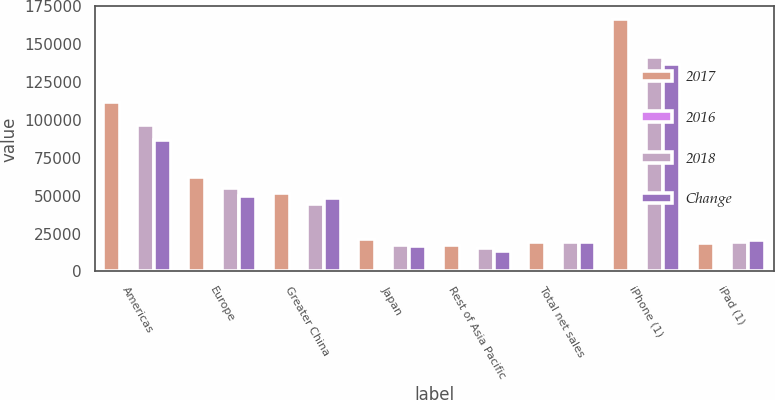<chart> <loc_0><loc_0><loc_500><loc_500><stacked_bar_chart><ecel><fcel>Americas<fcel>Europe<fcel>Greater China<fcel>Japan<fcel>Rest of Asia Pacific<fcel>Total net sales<fcel>iPhone (1)<fcel>iPad (1)<nl><fcel>2017<fcel>112093<fcel>62420<fcel>51942<fcel>21733<fcel>17407<fcel>19222<fcel>166699<fcel>18805<nl><fcel>2016<fcel>16<fcel>14<fcel>16<fcel>23<fcel>15<fcel>16<fcel>18<fcel>2<nl><fcel>2018<fcel>96600<fcel>54938<fcel>44764<fcel>17733<fcel>15199<fcel>19222<fcel>141319<fcel>19222<nl><fcel>Change<fcel>86613<fcel>49952<fcel>48492<fcel>16928<fcel>13654<fcel>19222<fcel>136700<fcel>20628<nl></chart> 